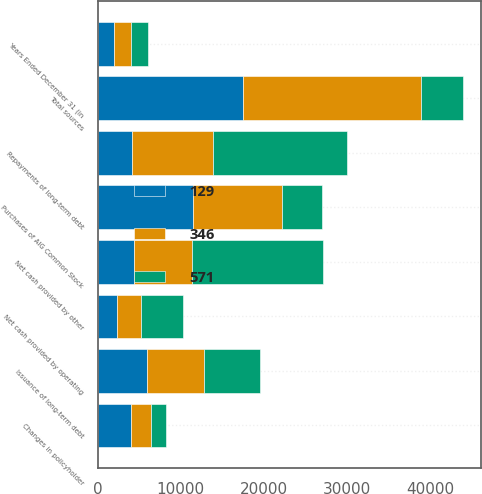Convert chart. <chart><loc_0><loc_0><loc_500><loc_500><stacked_bar_chart><ecel><fcel>Years Ended December 31 (in<fcel>Net cash provided by operating<fcel>Net cash provided by other<fcel>Changes in policyholder<fcel>Issuance of long-term debt<fcel>Total sources<fcel>Repayments of long-term debt<fcel>Purchases of AIG Common Stock<nl><fcel>129<fcel>2016<fcel>2383<fcel>4359<fcel>4059<fcel>5954<fcel>17517<fcel>4082<fcel>11460<nl><fcel>346<fcel>2015<fcel>2877<fcel>7005<fcel>2410<fcel>6867<fcel>21434<fcel>9805<fcel>10691<nl><fcel>571<fcel>2014<fcel>5007<fcel>15731<fcel>1719<fcel>6687<fcel>5007<fcel>16160<fcel>4902<nl></chart> 